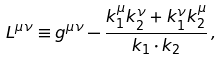<formula> <loc_0><loc_0><loc_500><loc_500>L ^ { \mu \nu } \equiv g ^ { \mu \nu } - \frac { k _ { 1 } ^ { \mu } k _ { 2 } ^ { \nu } + k _ { 1 } ^ { \nu } k _ { 2 } ^ { \mu } } { k _ { 1 } \cdot k _ { 2 } } \, ,</formula> 